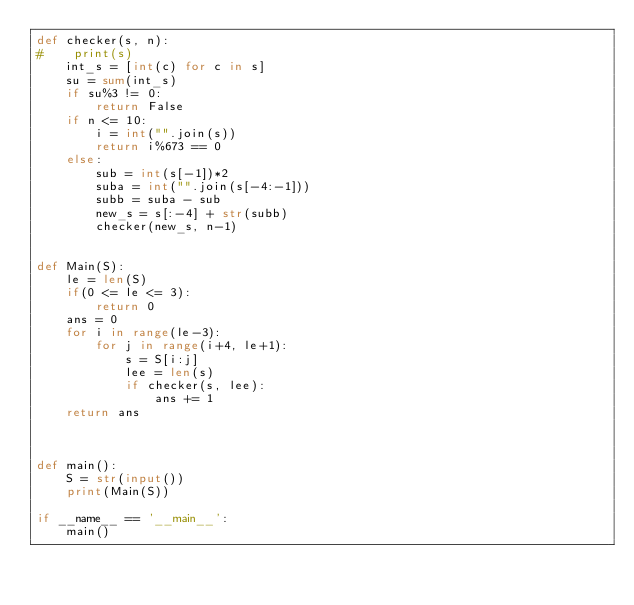Convert code to text. <code><loc_0><loc_0><loc_500><loc_500><_Python_>def checker(s, n):
#    print(s)
    int_s = [int(c) for c in s]
    su = sum(int_s)
    if su%3 != 0:
        return False
    if n <= 10:
        i = int("".join(s))
        return i%673 == 0
    else:
        sub = int(s[-1])*2
        suba = int("".join(s[-4:-1]))
        subb = suba - sub
        new_s = s[:-4] + str(subb)
        checker(new_s, n-1)
    

def Main(S):
    le = len(S)
    if(0 <= le <= 3):
        return 0
    ans = 0
    for i in range(le-3):
        for j in range(i+4, le+1):
            s = S[i:j]
            lee = len(s)
            if checker(s, lee):
                ans += 1
    return ans
            


def main():
    S = str(input())
    print(Main(S))

if __name__ == '__main__':
    main()</code> 